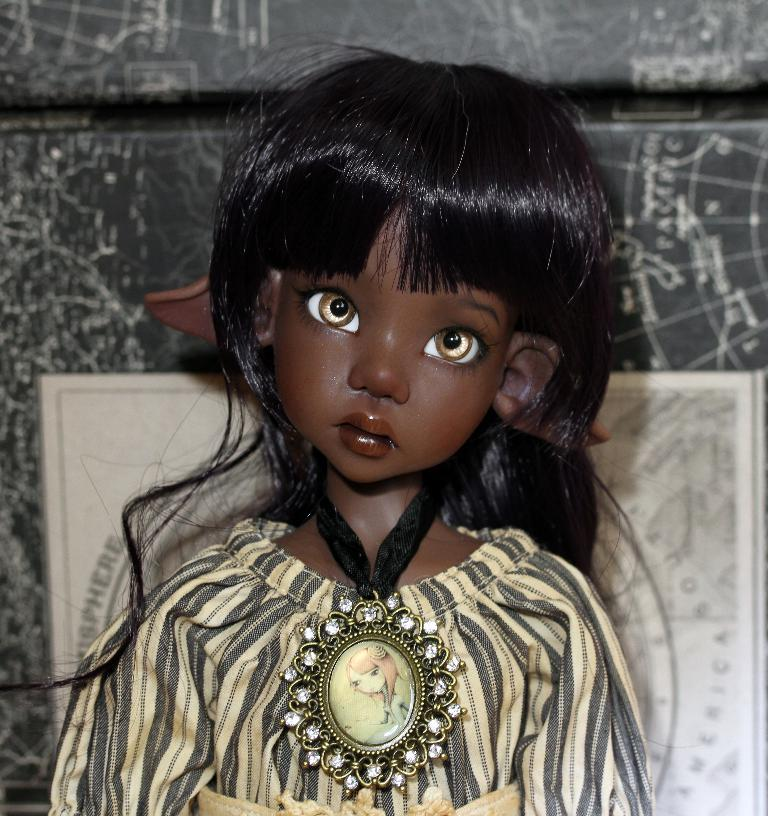What is the main subject in the front of the image? There is a doll in the front of the image. What can be seen in the background of the image? There is a wall in the background of the image. What type of dinosaurs can be seen on the stage in the image? There is no stage or dinosaurs present in the image; it features a doll in the front and a wall in the background. 